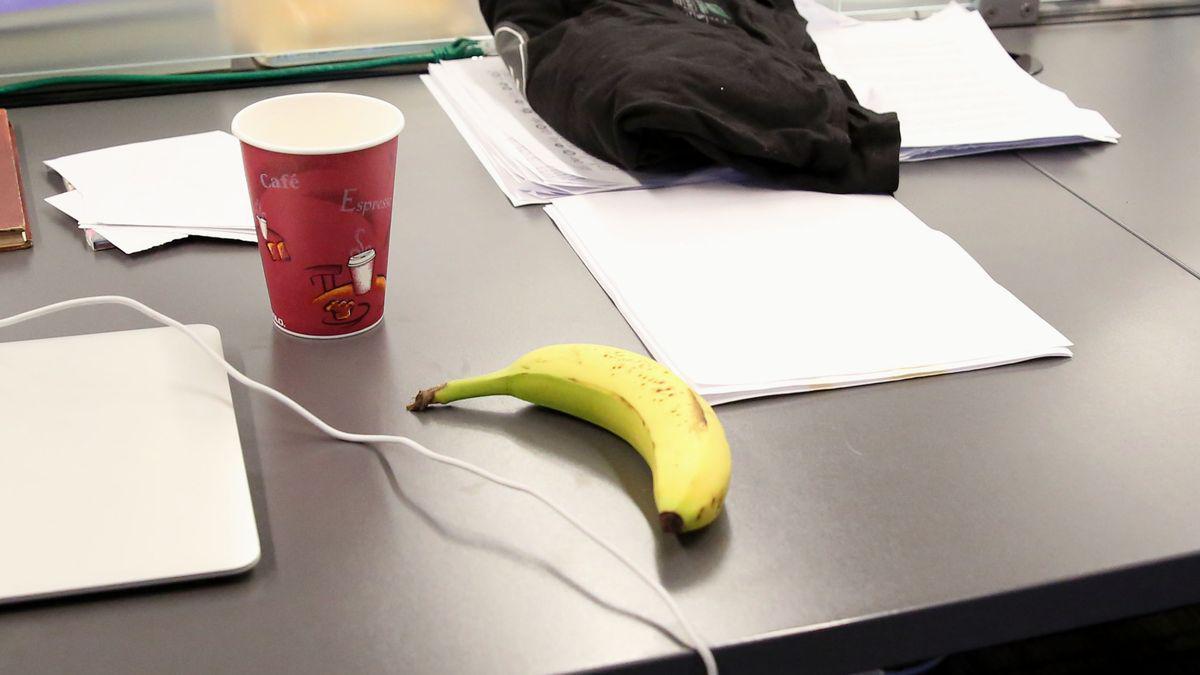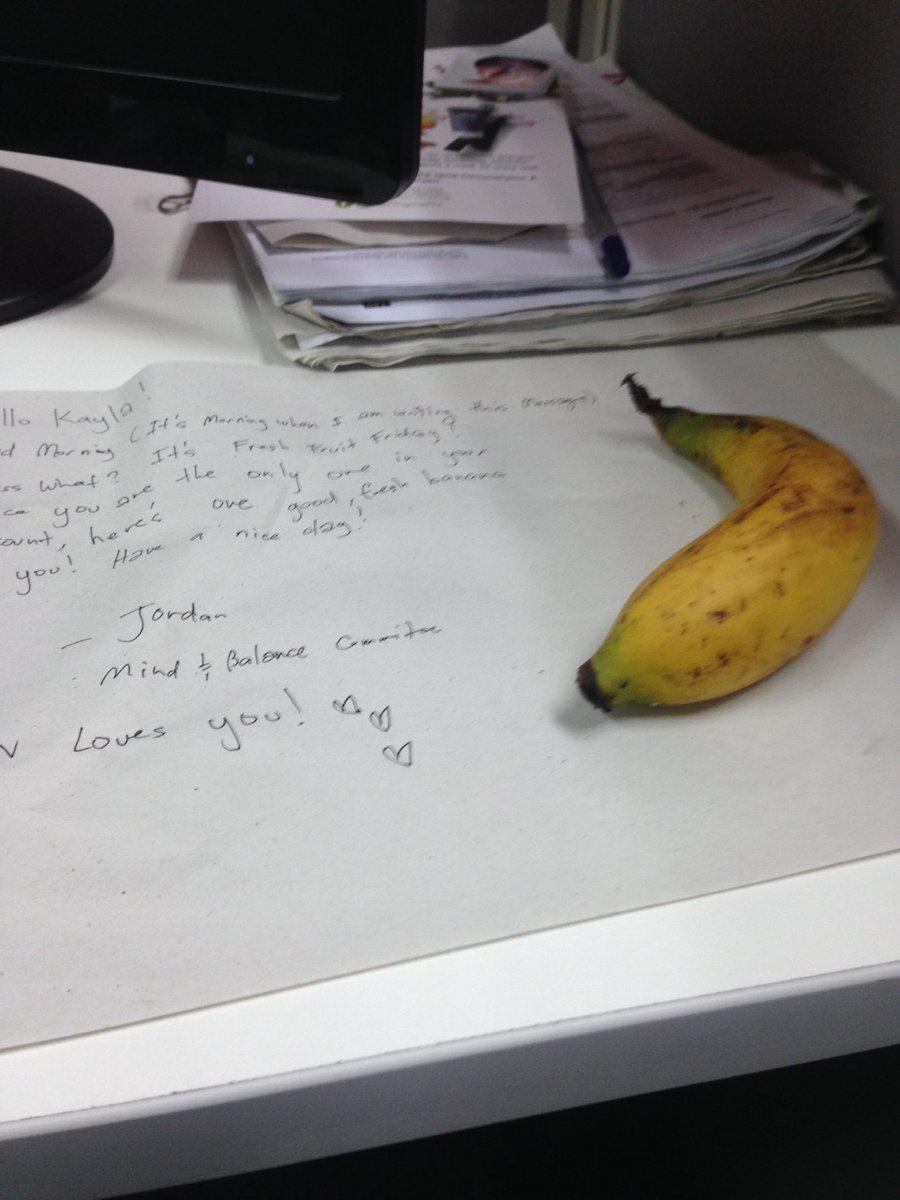The first image is the image on the left, the second image is the image on the right. Given the left and right images, does the statement "Two bananas are sitting on a desk, and at least one of them is sitting beside a piece of paper." hold true? Answer yes or no. Yes. The first image is the image on the left, the second image is the image on the right. Evaluate the accuracy of this statement regarding the images: "A banana is on a reddish-brown woodgrain surface in the right image, and a banana is by a cup-like container in the left image.". Is it true? Answer yes or no. No. 